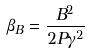<formula> <loc_0><loc_0><loc_500><loc_500>\beta _ { B } = \frac { B ^ { 2 } } { 2 P \gamma ^ { 2 } }</formula> 